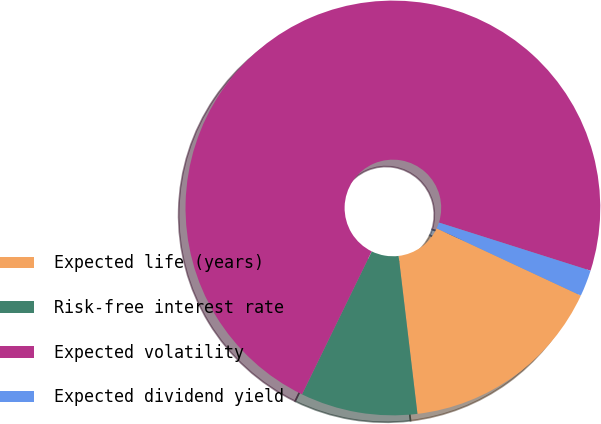<chart> <loc_0><loc_0><loc_500><loc_500><pie_chart><fcel>Expected life (years)<fcel>Risk-free interest rate<fcel>Expected volatility<fcel>Expected dividend yield<nl><fcel>16.17%<fcel>9.11%<fcel>72.67%<fcel>2.05%<nl></chart> 